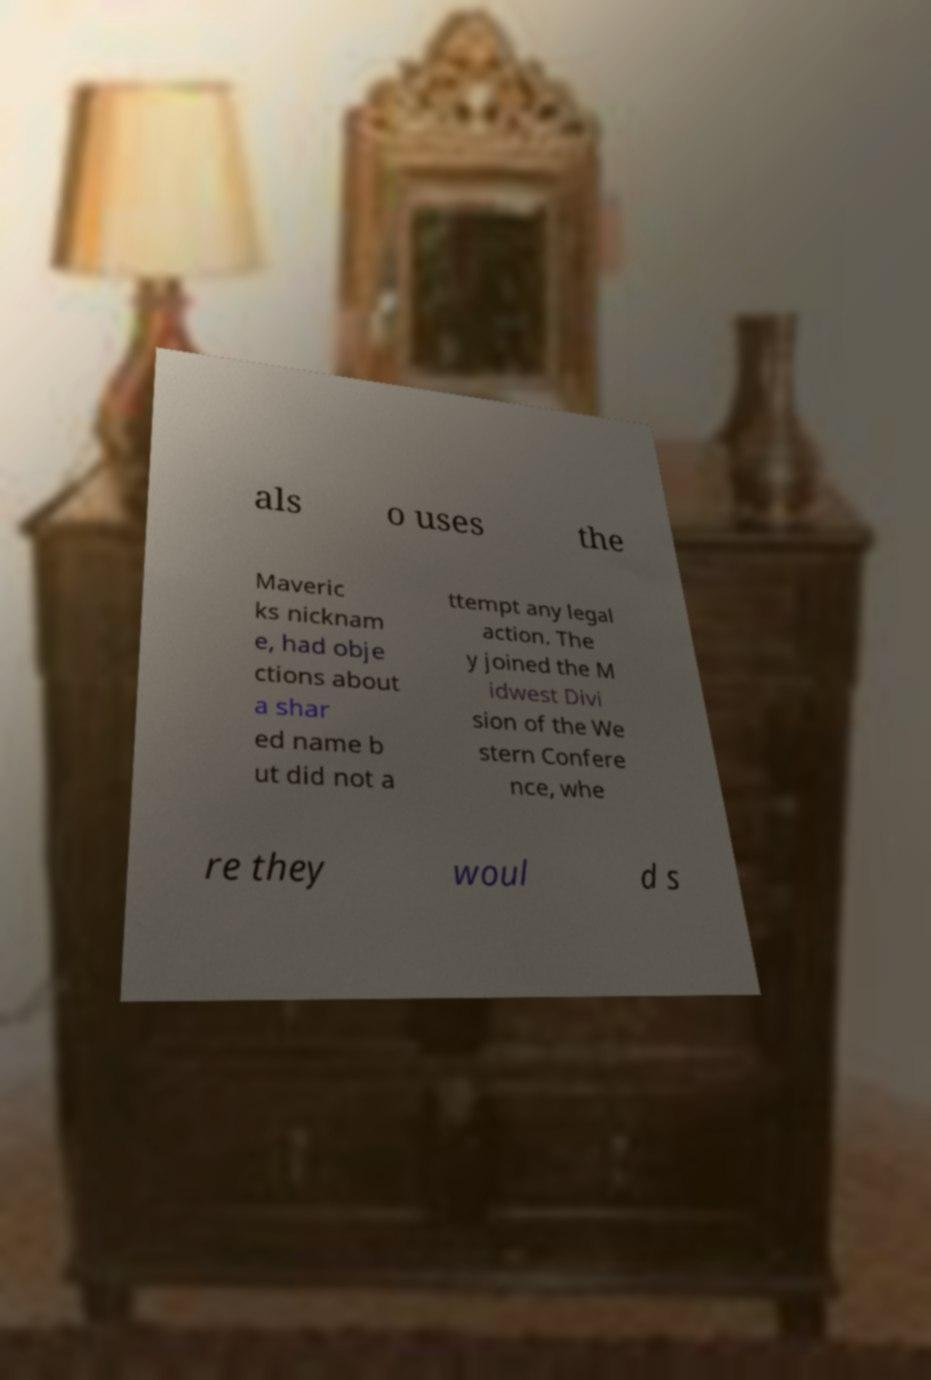Please read and relay the text visible in this image. What does it say? als o uses the Maveric ks nicknam e, had obje ctions about a shar ed name b ut did not a ttempt any legal action. The y joined the M idwest Divi sion of the We stern Confere nce, whe re they woul d s 